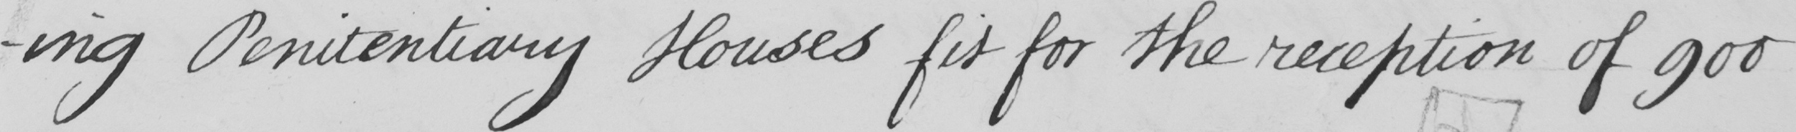What text is written in this handwritten line? -ng Penitentiary Houses fit for the reception of 900 